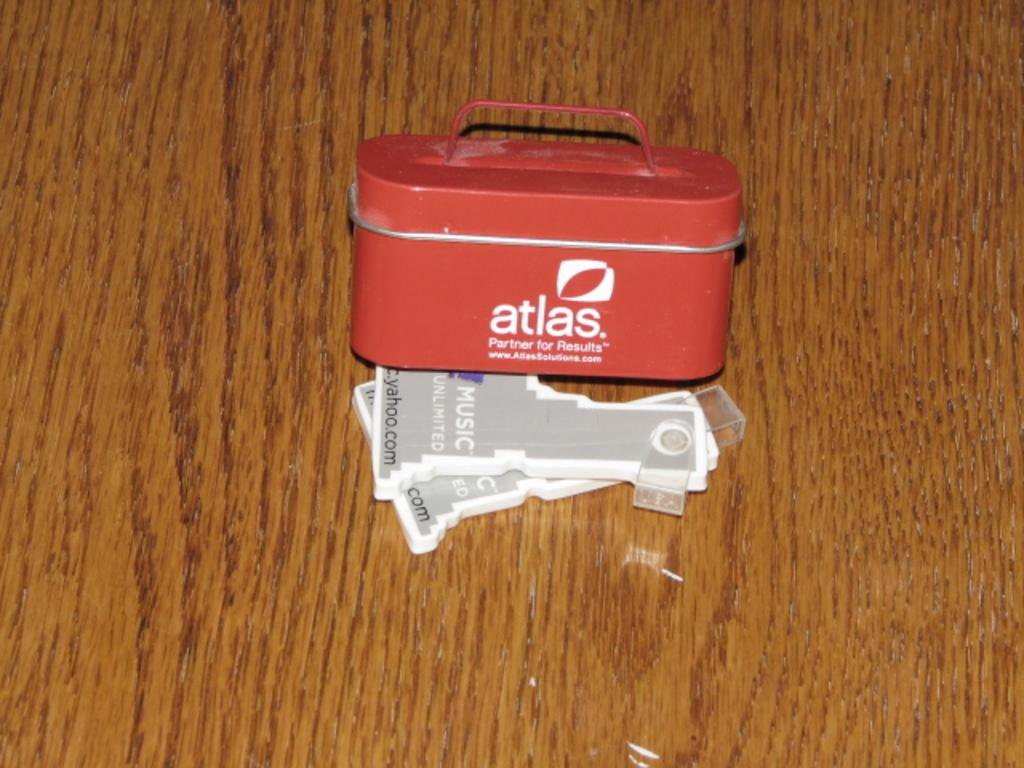<image>
Render a clear and concise summary of the photo. A small tin with a handle says Atlas on it. 